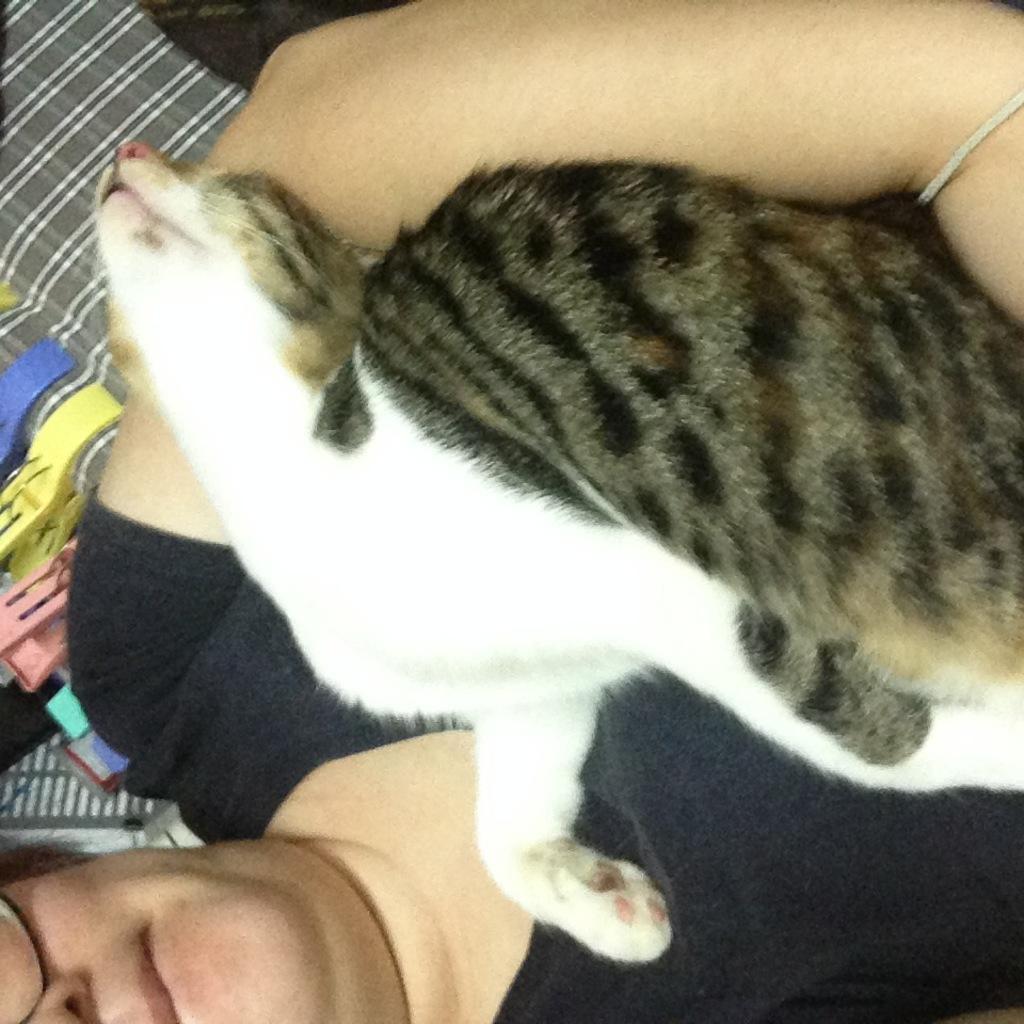Describe this image in one or two sentences. In this image I can see the person holding the cat and the cat is in brown and black color and the person is wearing black color shirt. In the background I can see few clips in multicolor. 